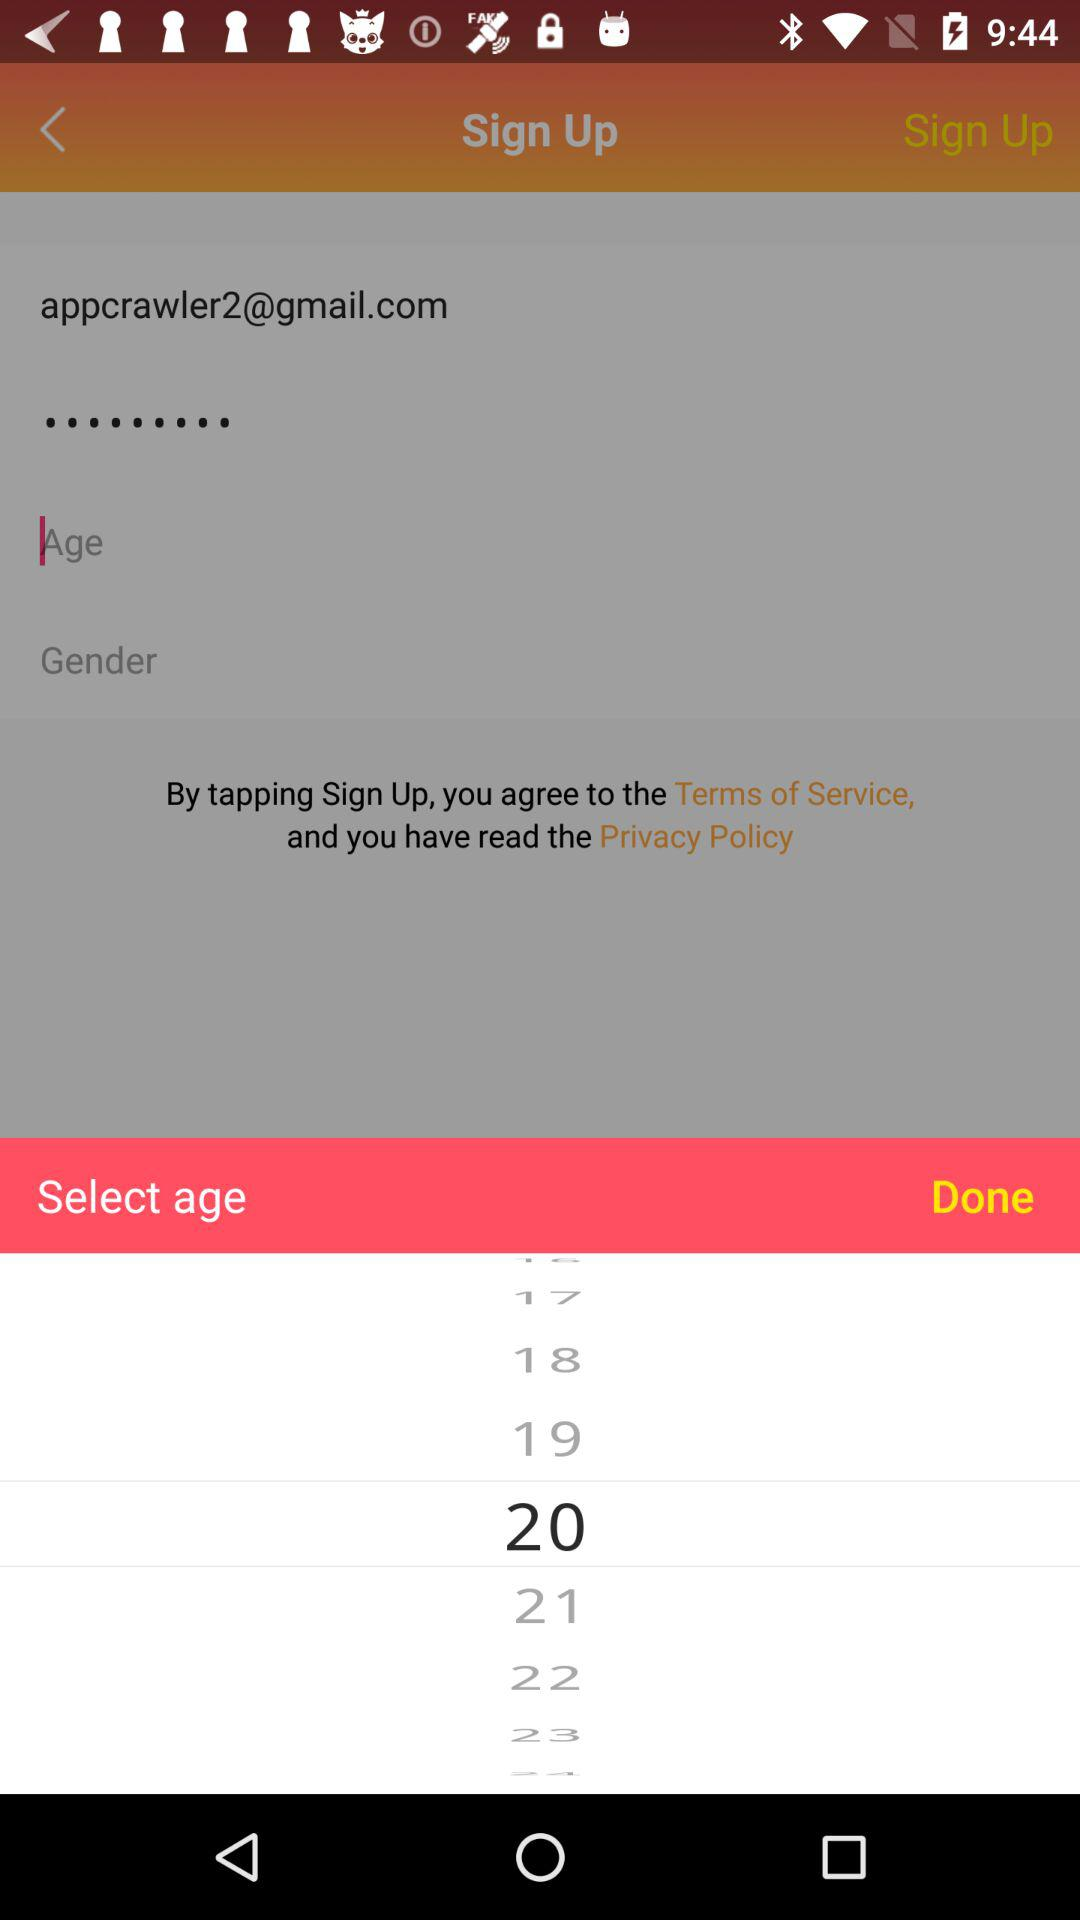What is the selected age? The selected age is "20". 